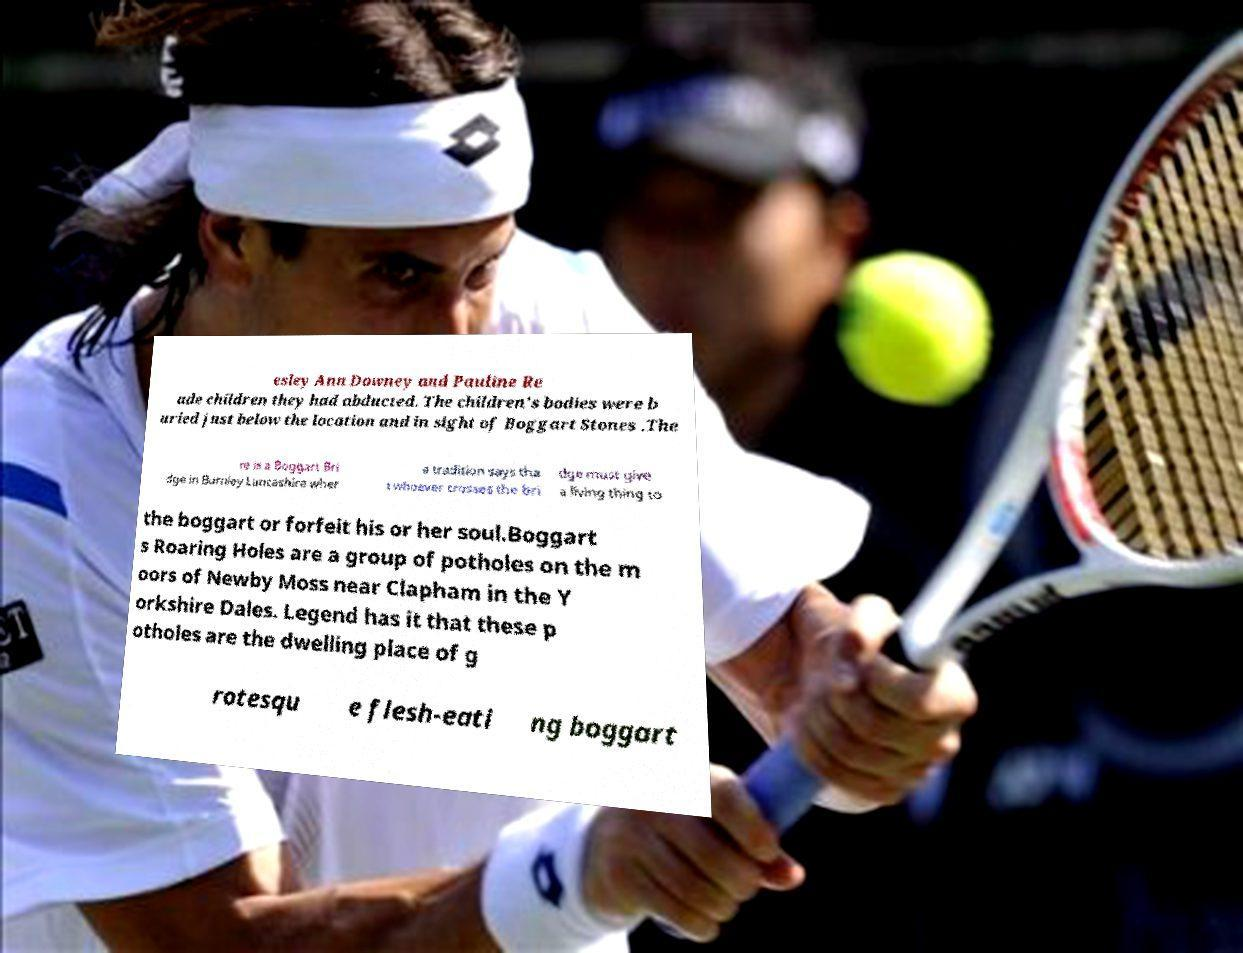What messages or text are displayed in this image? I need them in a readable, typed format. esley Ann Downey and Pauline Re ade children they had abducted. The children's bodies were b uried just below the location and in sight of Boggart Stones .The re is a Boggart Bri dge in Burnley Lancashire wher e tradition says tha t whoever crosses the bri dge must give a living thing to the boggart or forfeit his or her soul.Boggart s Roaring Holes are a group of potholes on the m oors of Newby Moss near Clapham in the Y orkshire Dales. Legend has it that these p otholes are the dwelling place of g rotesqu e flesh-eati ng boggart 